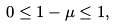<formula> <loc_0><loc_0><loc_500><loc_500>0 \leq 1 - \mu \leq 1 ,</formula> 